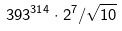<formula> <loc_0><loc_0><loc_500><loc_500>3 9 3 ^ { 3 1 4 } \cdot 2 ^ { 7 } / \sqrt { 1 0 }</formula> 